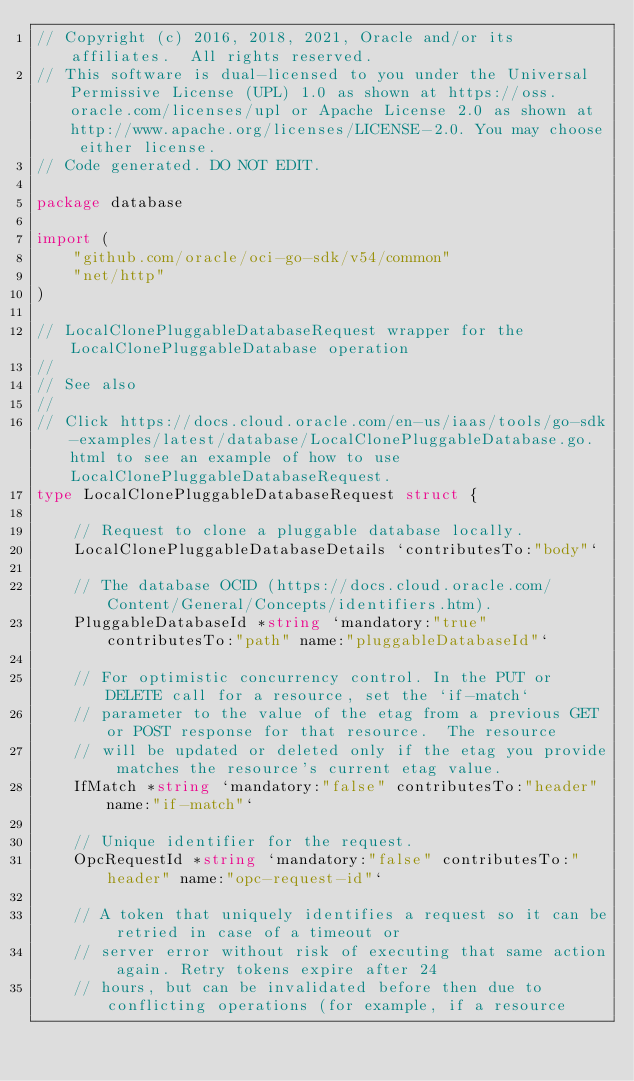Convert code to text. <code><loc_0><loc_0><loc_500><loc_500><_Go_>// Copyright (c) 2016, 2018, 2021, Oracle and/or its affiliates.  All rights reserved.
// This software is dual-licensed to you under the Universal Permissive License (UPL) 1.0 as shown at https://oss.oracle.com/licenses/upl or Apache License 2.0 as shown at http://www.apache.org/licenses/LICENSE-2.0. You may choose either license.
// Code generated. DO NOT EDIT.

package database

import (
	"github.com/oracle/oci-go-sdk/v54/common"
	"net/http"
)

// LocalClonePluggableDatabaseRequest wrapper for the LocalClonePluggableDatabase operation
//
// See also
//
// Click https://docs.cloud.oracle.com/en-us/iaas/tools/go-sdk-examples/latest/database/LocalClonePluggableDatabase.go.html to see an example of how to use LocalClonePluggableDatabaseRequest.
type LocalClonePluggableDatabaseRequest struct {

	// Request to clone a pluggable database locally.
	LocalClonePluggableDatabaseDetails `contributesTo:"body"`

	// The database OCID (https://docs.cloud.oracle.com/Content/General/Concepts/identifiers.htm).
	PluggableDatabaseId *string `mandatory:"true" contributesTo:"path" name:"pluggableDatabaseId"`

	// For optimistic concurrency control. In the PUT or DELETE call for a resource, set the `if-match`
	// parameter to the value of the etag from a previous GET or POST response for that resource.  The resource
	// will be updated or deleted only if the etag you provide matches the resource's current etag value.
	IfMatch *string `mandatory:"false" contributesTo:"header" name:"if-match"`

	// Unique identifier for the request.
	OpcRequestId *string `mandatory:"false" contributesTo:"header" name:"opc-request-id"`

	// A token that uniquely identifies a request so it can be retried in case of a timeout or
	// server error without risk of executing that same action again. Retry tokens expire after 24
	// hours, but can be invalidated before then due to conflicting operations (for example, if a resource</code> 